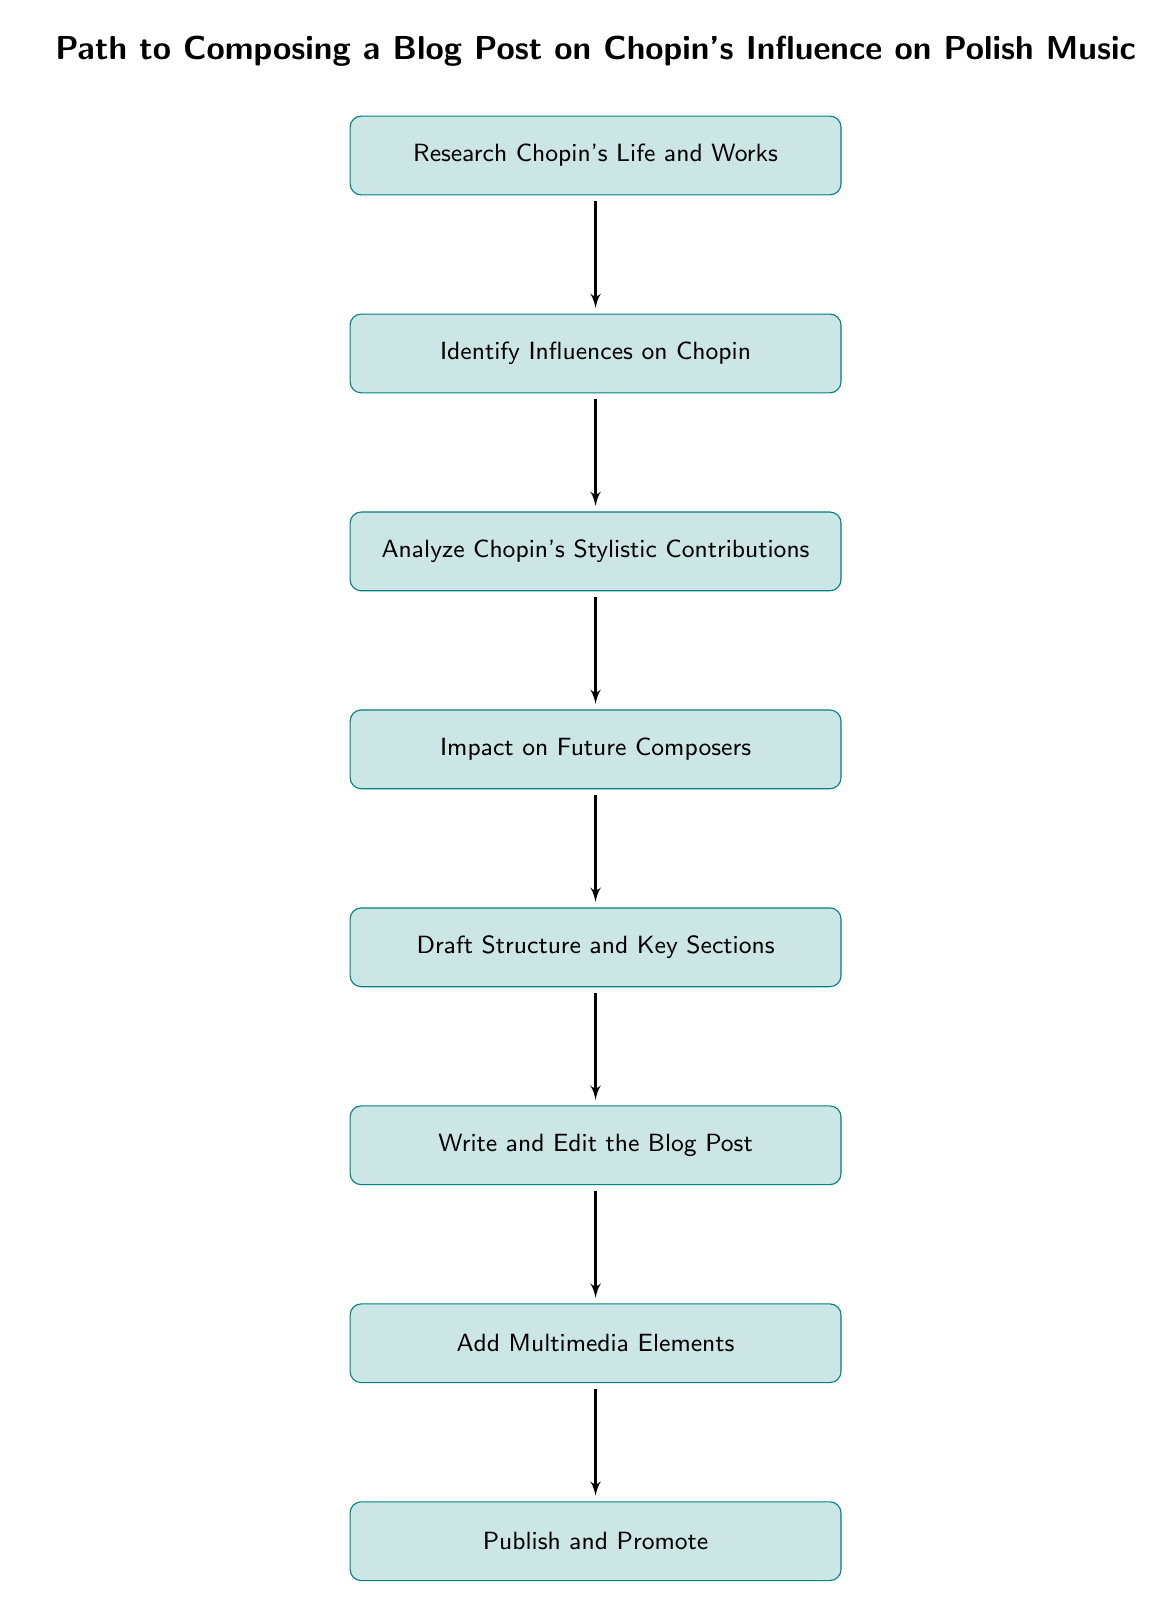What is the first step in the flow chart? The first node in the flow chart is "Research Chopin's Life and Works," indicating the starting point of the process of composing the blog post.
Answer: Research Chopin's Life and Works Which two elements are directly connected in the flow chart? Each node has a connection (edge) indicating the progression of steps. For example, "Research Chopin's Life and Works" is connected to "Identify Influences on Chopin," showing that one leads to the next.
Answer: Research Chopin's Life and Works and Identify Influences on Chopin How many nodes are present in the diagram? By counting all identifiable blocks in the diagram, we can see there are eight steps, which are all defined as nodes.
Answer: 8 What is the last step before publishing? The node just before "Publish and Promote" is "Add Multimedia Elements," indicating the last preparation before the final action of publishing.
Answer: Add Multimedia Elements What is the purpose of the fourth step in the process? The fourth step, "Impact on Future Composers," examines the influence that Chopin had on subsequent Polish composers, which is critical to understanding his overall impact on music.
Answer: Examine influence Which step immediately follows analyzing Chopin's stylistic contributions? The step that comes immediately after "Analyze Chopin's Stylistic Contributions" is "Impact on Future Composers," indicating the next logical stage of exploration.
Answer: Impact on Future Composers What type of elements should be included in the blog post according to the diagram? The diagram specifies adding "multimedia elements," which suggests incorporating various forms of media to enrich the content of the blog post.
Answer: Multimedia elements What is the sequential order of steps from drafting to sharing? The sequence is "Draft Structure and Key Sections," followed by "Write and Edit the Blog Post," then "Add Multimedia Elements," and finally "Publish and Promote," illustrating a clear progression toward publication.
Answer: Draft Structure and Key Sections, Write and Edit the Blog Post, Add Multimedia Elements, Publish and Promote 